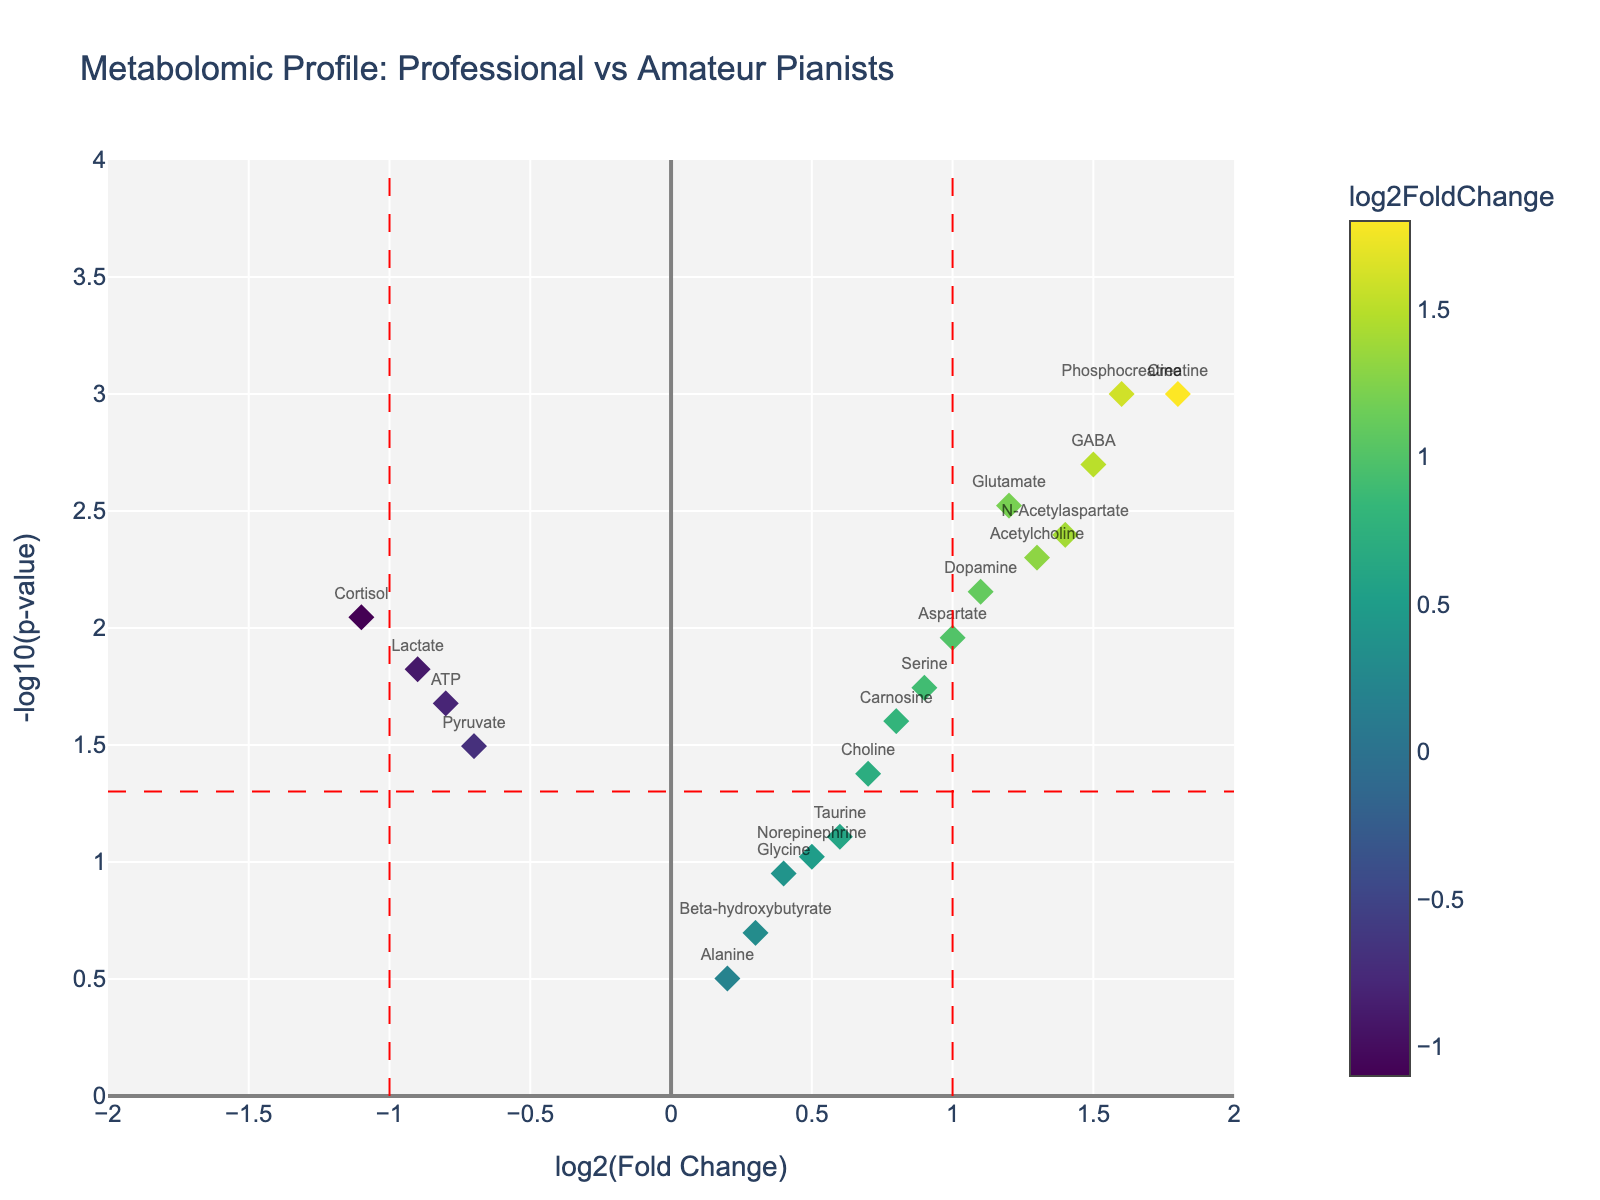what is the title of the plot? The title is usually displayed at the top of the plot area. By reading it, we can understand what the plot is about.
Answer: "Metabolomic Profile: Professional vs Amateur Pianists" How many metabolites have a log2FoldChange greater than 1? We need to count the number of data points (metabolites) with an `x` value (log2FoldChange) greater than 1. From the plot, looking at the data points to the right of the vertical line at x = 1 helps us count quickly.
Answer: 7 What is the log2FoldChange and p-value of Creatine? By hovering over or reading the annotated data point labeled "Creatine," you can find both the log2FoldChange and p-value.
Answer: 1.8, 0.001 Which metabolite has the most significant upregulation? To find the most significantly upregulated metabolite, we look for the point with the highest log2FoldChange value in the positive direction which also has a low p-value indicated by its position high in the plot.
Answer: Creatine Are there any downregulated metabolites? Downregulated metabolites will have negative log2FoldChange values. By looking at points to the left of the center (x=0) line, we can identify the downregulated metabolites.
Answer: Yes Which metabolite has the lowest p-value among the downregulated ones? Among the downregulated metabolites, we need to find the point that is highest on the y-axis (indicating the lowest p-value). This is achieved by looking at the data points on the left side of the plot.
Answer: Cortisol What does the vertical dashed line at x=1 indicate? The vertical dashed lines are drawn at x-values of 1 and -1, likely marking fold change thresholds to highlight significantly changed metabolites. The line at x=1 marks the threshold above which metabolites are considered significantly upregulated.
Answer: Threshold for significant upregulation Which metabolites are considered not significantly different between the groups? Metabolites within the vertical dashed lines at x=-1 and x=1 and below the horizontal dashed line at -log10(p-value) around 1.3 (corresponding to p=0.05) are considered not significantly different.
Answer: Taurine, Glycine, Norepinephrine, Beta-hydroxybutyrate, Alanine How many metabolites have a p-value less than 0.01? To determine this, look for data points that are above the y=-log10(0.01) = 2 threshold. Count these points in the plot.
Answer: 7 Which metabolite appears to be the closest to the threshold for upregulation significance? We need to find the metabolite that is closer to the vertical line at x=1 but within a small range below it, and simultaneously with a p-value close to 0.05.
Answer: Choline 